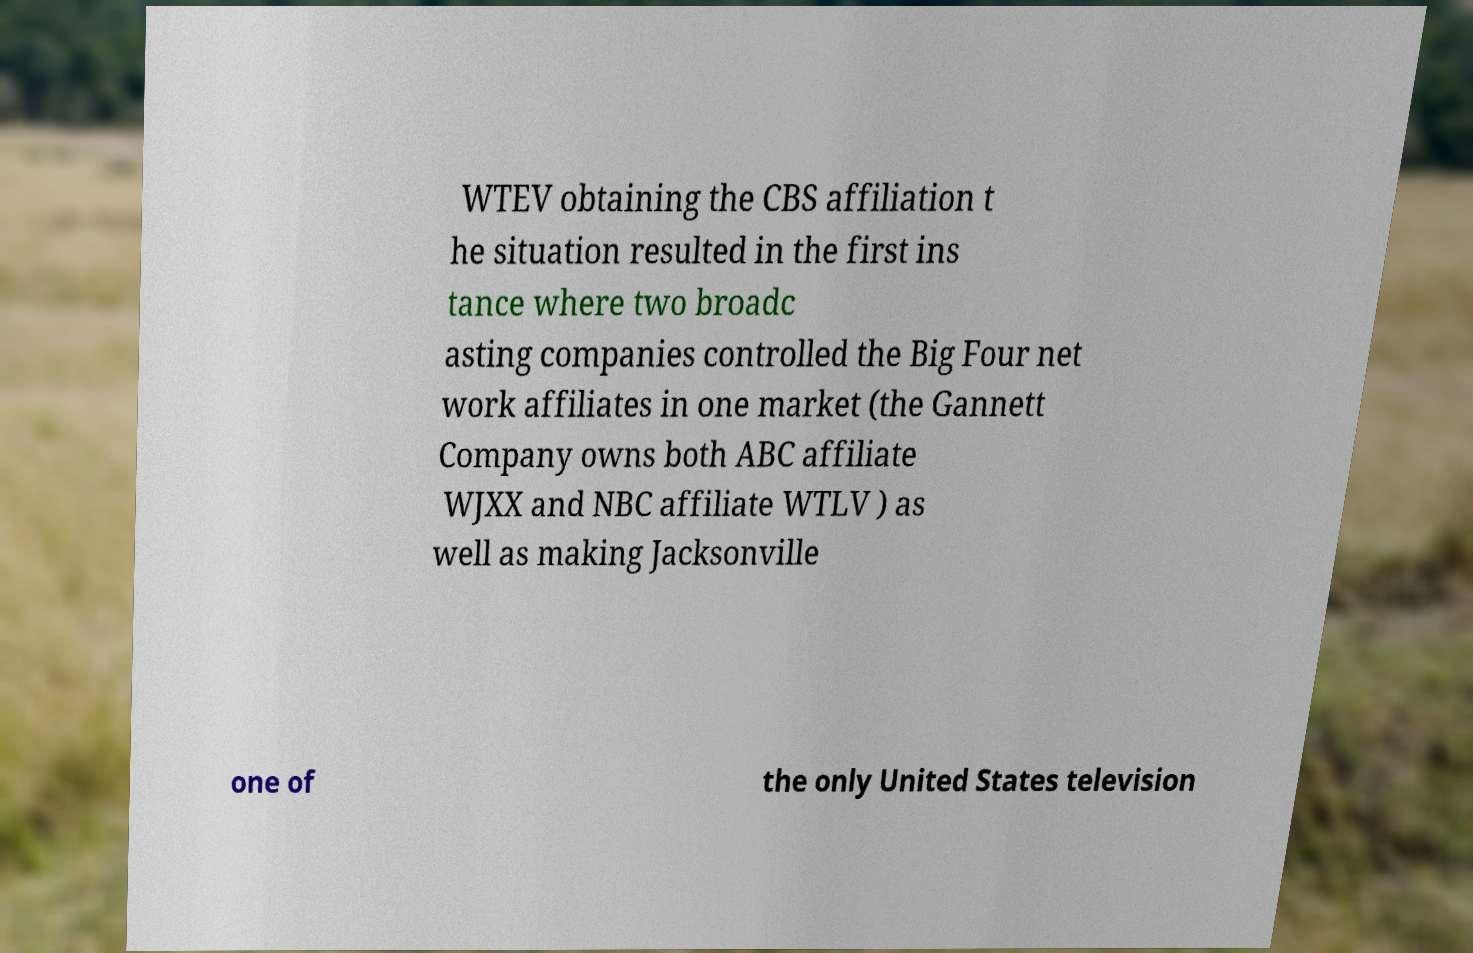Can you accurately transcribe the text from the provided image for me? WTEV obtaining the CBS affiliation t he situation resulted in the first ins tance where two broadc asting companies controlled the Big Four net work affiliates in one market (the Gannett Company owns both ABC affiliate WJXX and NBC affiliate WTLV ) as well as making Jacksonville one of the only United States television 